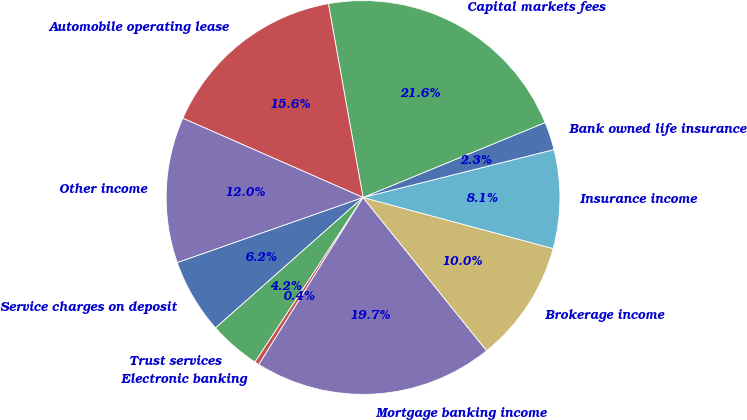<chart> <loc_0><loc_0><loc_500><loc_500><pie_chart><fcel>Service charges on deposit<fcel>Trust services<fcel>Electronic banking<fcel>Mortgage banking income<fcel>Brokerage income<fcel>Insurance income<fcel>Bank owned life insurance<fcel>Capital markets fees<fcel>Automobile operating lease<fcel>Other income<nl><fcel>6.16%<fcel>4.23%<fcel>0.37%<fcel>19.67%<fcel>10.02%<fcel>8.09%<fcel>2.3%<fcel>21.6%<fcel>15.59%<fcel>11.95%<nl></chart> 